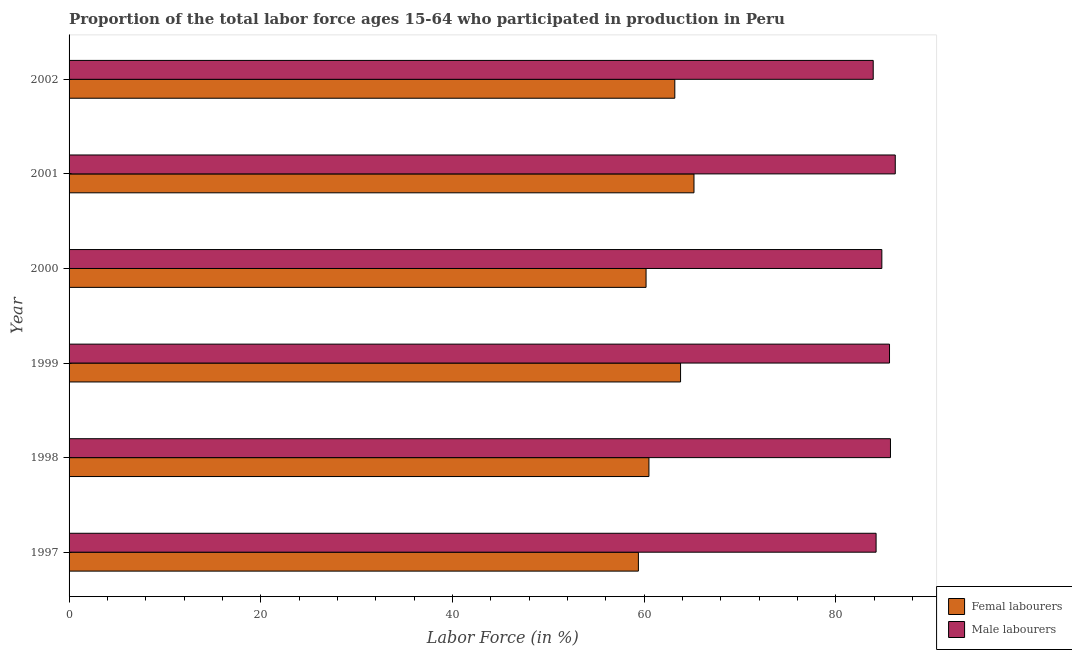How many bars are there on the 3rd tick from the bottom?
Provide a succinct answer. 2. What is the label of the 2nd group of bars from the top?
Your answer should be compact. 2001. What is the percentage of male labour force in 2001?
Your response must be concise. 86.2. Across all years, what is the maximum percentage of female labor force?
Give a very brief answer. 65.2. Across all years, what is the minimum percentage of male labour force?
Your answer should be compact. 83.9. What is the total percentage of male labour force in the graph?
Offer a terse response. 510.4. What is the difference between the percentage of male labour force in 2002 and the percentage of female labor force in 1997?
Provide a succinct answer. 24.5. What is the average percentage of male labour force per year?
Your response must be concise. 85.07. In the year 1998, what is the difference between the percentage of male labour force and percentage of female labor force?
Give a very brief answer. 25.2. In how many years, is the percentage of male labour force greater than 72 %?
Provide a succinct answer. 6. What does the 1st bar from the top in 1997 represents?
Provide a short and direct response. Male labourers. What does the 1st bar from the bottom in 1998 represents?
Make the answer very short. Femal labourers. How many bars are there?
Provide a short and direct response. 12. Are all the bars in the graph horizontal?
Your answer should be very brief. Yes. What is the difference between two consecutive major ticks on the X-axis?
Keep it short and to the point. 20. Are the values on the major ticks of X-axis written in scientific E-notation?
Provide a succinct answer. No. Does the graph contain any zero values?
Offer a terse response. No. How many legend labels are there?
Your answer should be compact. 2. What is the title of the graph?
Ensure brevity in your answer.  Proportion of the total labor force ages 15-64 who participated in production in Peru. What is the label or title of the Y-axis?
Provide a succinct answer. Year. What is the Labor Force (in %) in Femal labourers in 1997?
Provide a succinct answer. 59.4. What is the Labor Force (in %) in Male labourers in 1997?
Ensure brevity in your answer.  84.2. What is the Labor Force (in %) in Femal labourers in 1998?
Offer a very short reply. 60.5. What is the Labor Force (in %) in Male labourers in 1998?
Your answer should be very brief. 85.7. What is the Labor Force (in %) of Femal labourers in 1999?
Provide a short and direct response. 63.8. What is the Labor Force (in %) of Male labourers in 1999?
Provide a succinct answer. 85.6. What is the Labor Force (in %) of Femal labourers in 2000?
Provide a succinct answer. 60.2. What is the Labor Force (in %) in Male labourers in 2000?
Make the answer very short. 84.8. What is the Labor Force (in %) in Femal labourers in 2001?
Give a very brief answer. 65.2. What is the Labor Force (in %) in Male labourers in 2001?
Make the answer very short. 86.2. What is the Labor Force (in %) of Femal labourers in 2002?
Keep it short and to the point. 63.2. What is the Labor Force (in %) of Male labourers in 2002?
Offer a terse response. 83.9. Across all years, what is the maximum Labor Force (in %) in Femal labourers?
Provide a short and direct response. 65.2. Across all years, what is the maximum Labor Force (in %) in Male labourers?
Offer a very short reply. 86.2. Across all years, what is the minimum Labor Force (in %) in Femal labourers?
Your answer should be very brief. 59.4. Across all years, what is the minimum Labor Force (in %) in Male labourers?
Your answer should be compact. 83.9. What is the total Labor Force (in %) in Femal labourers in the graph?
Your response must be concise. 372.3. What is the total Labor Force (in %) of Male labourers in the graph?
Ensure brevity in your answer.  510.4. What is the difference between the Labor Force (in %) in Femal labourers in 1997 and that in 1998?
Your answer should be very brief. -1.1. What is the difference between the Labor Force (in %) in Male labourers in 1997 and that in 1998?
Give a very brief answer. -1.5. What is the difference between the Labor Force (in %) of Femal labourers in 1997 and that in 2000?
Your answer should be compact. -0.8. What is the difference between the Labor Force (in %) in Femal labourers in 1997 and that in 2001?
Make the answer very short. -5.8. What is the difference between the Labor Force (in %) in Femal labourers in 1998 and that in 2000?
Provide a succinct answer. 0.3. What is the difference between the Labor Force (in %) in Femal labourers in 1998 and that in 2002?
Provide a succinct answer. -2.7. What is the difference between the Labor Force (in %) in Male labourers in 1998 and that in 2002?
Provide a short and direct response. 1.8. What is the difference between the Labor Force (in %) in Femal labourers in 1999 and that in 2000?
Offer a very short reply. 3.6. What is the difference between the Labor Force (in %) in Femal labourers in 1999 and that in 2001?
Offer a very short reply. -1.4. What is the difference between the Labor Force (in %) in Male labourers in 1999 and that in 2002?
Your response must be concise. 1.7. What is the difference between the Labor Force (in %) of Femal labourers in 2000 and that in 2001?
Your answer should be very brief. -5. What is the difference between the Labor Force (in %) in Femal labourers in 2000 and that in 2002?
Provide a succinct answer. -3. What is the difference between the Labor Force (in %) in Femal labourers in 2001 and that in 2002?
Your response must be concise. 2. What is the difference between the Labor Force (in %) in Male labourers in 2001 and that in 2002?
Offer a terse response. 2.3. What is the difference between the Labor Force (in %) of Femal labourers in 1997 and the Labor Force (in %) of Male labourers in 1998?
Your answer should be very brief. -26.3. What is the difference between the Labor Force (in %) in Femal labourers in 1997 and the Labor Force (in %) in Male labourers in 1999?
Offer a very short reply. -26.2. What is the difference between the Labor Force (in %) of Femal labourers in 1997 and the Labor Force (in %) of Male labourers in 2000?
Provide a short and direct response. -25.4. What is the difference between the Labor Force (in %) of Femal labourers in 1997 and the Labor Force (in %) of Male labourers in 2001?
Make the answer very short. -26.8. What is the difference between the Labor Force (in %) in Femal labourers in 1997 and the Labor Force (in %) in Male labourers in 2002?
Offer a terse response. -24.5. What is the difference between the Labor Force (in %) of Femal labourers in 1998 and the Labor Force (in %) of Male labourers in 1999?
Provide a short and direct response. -25.1. What is the difference between the Labor Force (in %) of Femal labourers in 1998 and the Labor Force (in %) of Male labourers in 2000?
Provide a short and direct response. -24.3. What is the difference between the Labor Force (in %) in Femal labourers in 1998 and the Labor Force (in %) in Male labourers in 2001?
Your answer should be compact. -25.7. What is the difference between the Labor Force (in %) in Femal labourers in 1998 and the Labor Force (in %) in Male labourers in 2002?
Your response must be concise. -23.4. What is the difference between the Labor Force (in %) of Femal labourers in 1999 and the Labor Force (in %) of Male labourers in 2000?
Make the answer very short. -21. What is the difference between the Labor Force (in %) in Femal labourers in 1999 and the Labor Force (in %) in Male labourers in 2001?
Offer a very short reply. -22.4. What is the difference between the Labor Force (in %) in Femal labourers in 1999 and the Labor Force (in %) in Male labourers in 2002?
Give a very brief answer. -20.1. What is the difference between the Labor Force (in %) of Femal labourers in 2000 and the Labor Force (in %) of Male labourers in 2001?
Ensure brevity in your answer.  -26. What is the difference between the Labor Force (in %) in Femal labourers in 2000 and the Labor Force (in %) in Male labourers in 2002?
Provide a short and direct response. -23.7. What is the difference between the Labor Force (in %) in Femal labourers in 2001 and the Labor Force (in %) in Male labourers in 2002?
Offer a very short reply. -18.7. What is the average Labor Force (in %) of Femal labourers per year?
Make the answer very short. 62.05. What is the average Labor Force (in %) of Male labourers per year?
Give a very brief answer. 85.07. In the year 1997, what is the difference between the Labor Force (in %) in Femal labourers and Labor Force (in %) in Male labourers?
Your answer should be compact. -24.8. In the year 1998, what is the difference between the Labor Force (in %) of Femal labourers and Labor Force (in %) of Male labourers?
Make the answer very short. -25.2. In the year 1999, what is the difference between the Labor Force (in %) in Femal labourers and Labor Force (in %) in Male labourers?
Your response must be concise. -21.8. In the year 2000, what is the difference between the Labor Force (in %) of Femal labourers and Labor Force (in %) of Male labourers?
Offer a very short reply. -24.6. In the year 2001, what is the difference between the Labor Force (in %) of Femal labourers and Labor Force (in %) of Male labourers?
Provide a short and direct response. -21. In the year 2002, what is the difference between the Labor Force (in %) of Femal labourers and Labor Force (in %) of Male labourers?
Provide a succinct answer. -20.7. What is the ratio of the Labor Force (in %) in Femal labourers in 1997 to that in 1998?
Make the answer very short. 0.98. What is the ratio of the Labor Force (in %) of Male labourers in 1997 to that in 1998?
Your answer should be very brief. 0.98. What is the ratio of the Labor Force (in %) in Male labourers in 1997 to that in 1999?
Make the answer very short. 0.98. What is the ratio of the Labor Force (in %) in Femal labourers in 1997 to that in 2000?
Provide a short and direct response. 0.99. What is the ratio of the Labor Force (in %) of Femal labourers in 1997 to that in 2001?
Your answer should be compact. 0.91. What is the ratio of the Labor Force (in %) of Male labourers in 1997 to that in 2001?
Offer a terse response. 0.98. What is the ratio of the Labor Force (in %) of Femal labourers in 1997 to that in 2002?
Keep it short and to the point. 0.94. What is the ratio of the Labor Force (in %) in Male labourers in 1997 to that in 2002?
Offer a very short reply. 1. What is the ratio of the Labor Force (in %) in Femal labourers in 1998 to that in 1999?
Your response must be concise. 0.95. What is the ratio of the Labor Force (in %) of Male labourers in 1998 to that in 1999?
Make the answer very short. 1. What is the ratio of the Labor Force (in %) of Male labourers in 1998 to that in 2000?
Offer a terse response. 1.01. What is the ratio of the Labor Force (in %) of Femal labourers in 1998 to that in 2001?
Offer a very short reply. 0.93. What is the ratio of the Labor Force (in %) in Male labourers in 1998 to that in 2001?
Your response must be concise. 0.99. What is the ratio of the Labor Force (in %) of Femal labourers in 1998 to that in 2002?
Offer a very short reply. 0.96. What is the ratio of the Labor Force (in %) of Male labourers in 1998 to that in 2002?
Ensure brevity in your answer.  1.02. What is the ratio of the Labor Force (in %) in Femal labourers in 1999 to that in 2000?
Your response must be concise. 1.06. What is the ratio of the Labor Force (in %) of Male labourers in 1999 to that in 2000?
Offer a very short reply. 1.01. What is the ratio of the Labor Force (in %) in Femal labourers in 1999 to that in 2001?
Keep it short and to the point. 0.98. What is the ratio of the Labor Force (in %) of Male labourers in 1999 to that in 2001?
Your answer should be compact. 0.99. What is the ratio of the Labor Force (in %) of Femal labourers in 1999 to that in 2002?
Ensure brevity in your answer.  1.01. What is the ratio of the Labor Force (in %) of Male labourers in 1999 to that in 2002?
Offer a very short reply. 1.02. What is the ratio of the Labor Force (in %) of Femal labourers in 2000 to that in 2001?
Provide a short and direct response. 0.92. What is the ratio of the Labor Force (in %) of Male labourers in 2000 to that in 2001?
Offer a terse response. 0.98. What is the ratio of the Labor Force (in %) in Femal labourers in 2000 to that in 2002?
Provide a succinct answer. 0.95. What is the ratio of the Labor Force (in %) in Male labourers in 2000 to that in 2002?
Give a very brief answer. 1.01. What is the ratio of the Labor Force (in %) in Femal labourers in 2001 to that in 2002?
Your answer should be compact. 1.03. What is the ratio of the Labor Force (in %) in Male labourers in 2001 to that in 2002?
Your response must be concise. 1.03. What is the difference between the highest and the second highest Labor Force (in %) in Male labourers?
Offer a terse response. 0.5. What is the difference between the highest and the lowest Labor Force (in %) of Femal labourers?
Your response must be concise. 5.8. 